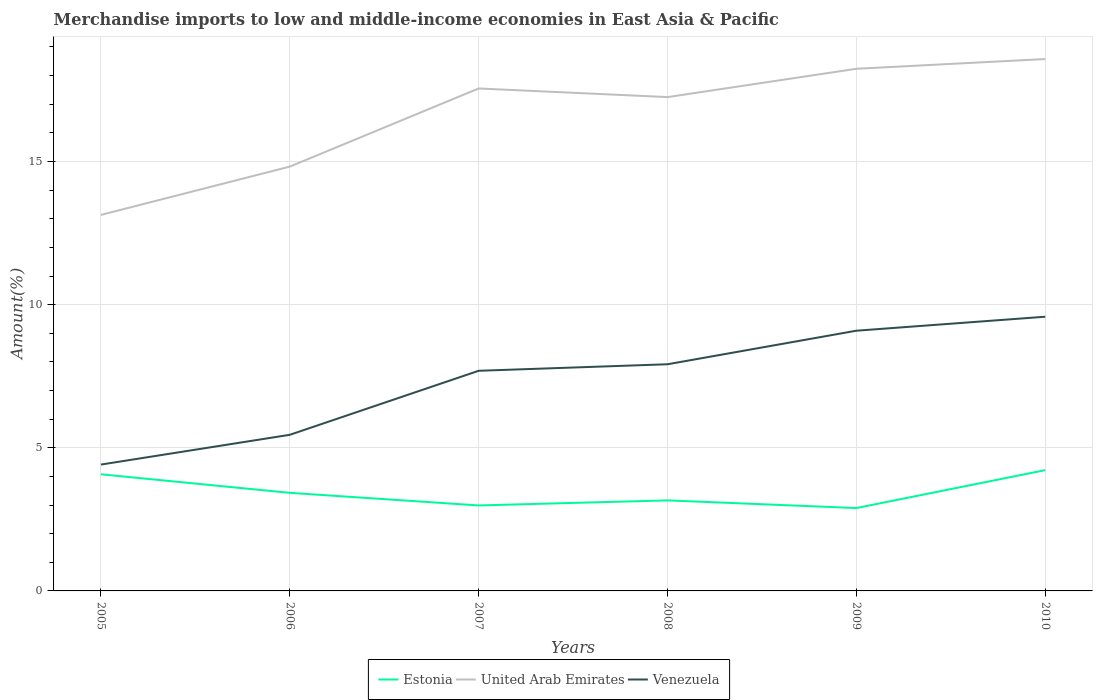How many different coloured lines are there?
Offer a very short reply. 3. Does the line corresponding to Venezuela intersect with the line corresponding to United Arab Emirates?
Offer a terse response. No. Across all years, what is the maximum percentage of amount earned from merchandise imports in Estonia?
Provide a succinct answer. 2.89. What is the total percentage of amount earned from merchandise imports in Estonia in the graph?
Provide a short and direct response. 0.53. What is the difference between the highest and the second highest percentage of amount earned from merchandise imports in United Arab Emirates?
Your answer should be compact. 5.44. What is the difference between the highest and the lowest percentage of amount earned from merchandise imports in Venezuela?
Offer a very short reply. 4. Is the percentage of amount earned from merchandise imports in Estonia strictly greater than the percentage of amount earned from merchandise imports in Venezuela over the years?
Your answer should be compact. Yes. How many lines are there?
Make the answer very short. 3. Does the graph contain any zero values?
Offer a very short reply. No. What is the title of the graph?
Your response must be concise. Merchandise imports to low and middle-income economies in East Asia & Pacific. Does "Cabo Verde" appear as one of the legend labels in the graph?
Ensure brevity in your answer.  No. What is the label or title of the X-axis?
Give a very brief answer. Years. What is the label or title of the Y-axis?
Provide a succinct answer. Amount(%). What is the Amount(%) in Estonia in 2005?
Your answer should be compact. 4.07. What is the Amount(%) in United Arab Emirates in 2005?
Offer a terse response. 13.13. What is the Amount(%) in Venezuela in 2005?
Your answer should be compact. 4.41. What is the Amount(%) in Estonia in 2006?
Give a very brief answer. 3.43. What is the Amount(%) of United Arab Emirates in 2006?
Your answer should be compact. 14.82. What is the Amount(%) of Venezuela in 2006?
Offer a very short reply. 5.45. What is the Amount(%) in Estonia in 2007?
Make the answer very short. 2.99. What is the Amount(%) in United Arab Emirates in 2007?
Offer a very short reply. 17.55. What is the Amount(%) in Venezuela in 2007?
Your response must be concise. 7.69. What is the Amount(%) of Estonia in 2008?
Your answer should be compact. 3.16. What is the Amount(%) of United Arab Emirates in 2008?
Your response must be concise. 17.25. What is the Amount(%) of Venezuela in 2008?
Your answer should be compact. 7.92. What is the Amount(%) of Estonia in 2009?
Keep it short and to the point. 2.89. What is the Amount(%) in United Arab Emirates in 2009?
Offer a terse response. 18.24. What is the Amount(%) in Venezuela in 2009?
Your answer should be very brief. 9.09. What is the Amount(%) in Estonia in 2010?
Provide a short and direct response. 4.22. What is the Amount(%) in United Arab Emirates in 2010?
Keep it short and to the point. 18.58. What is the Amount(%) of Venezuela in 2010?
Make the answer very short. 9.58. Across all years, what is the maximum Amount(%) in Estonia?
Give a very brief answer. 4.22. Across all years, what is the maximum Amount(%) in United Arab Emirates?
Your answer should be compact. 18.58. Across all years, what is the maximum Amount(%) in Venezuela?
Make the answer very short. 9.58. Across all years, what is the minimum Amount(%) of Estonia?
Make the answer very short. 2.89. Across all years, what is the minimum Amount(%) of United Arab Emirates?
Make the answer very short. 13.13. Across all years, what is the minimum Amount(%) of Venezuela?
Provide a short and direct response. 4.41. What is the total Amount(%) of Estonia in the graph?
Keep it short and to the point. 20.76. What is the total Amount(%) in United Arab Emirates in the graph?
Keep it short and to the point. 99.57. What is the total Amount(%) of Venezuela in the graph?
Give a very brief answer. 44.14. What is the difference between the Amount(%) of Estonia in 2005 and that in 2006?
Make the answer very short. 0.65. What is the difference between the Amount(%) in United Arab Emirates in 2005 and that in 2006?
Give a very brief answer. -1.69. What is the difference between the Amount(%) of Venezuela in 2005 and that in 2006?
Provide a short and direct response. -1.04. What is the difference between the Amount(%) in Estonia in 2005 and that in 2007?
Keep it short and to the point. 1.09. What is the difference between the Amount(%) in United Arab Emirates in 2005 and that in 2007?
Give a very brief answer. -4.42. What is the difference between the Amount(%) of Venezuela in 2005 and that in 2007?
Ensure brevity in your answer.  -3.28. What is the difference between the Amount(%) of Estonia in 2005 and that in 2008?
Your answer should be very brief. 0.91. What is the difference between the Amount(%) in United Arab Emirates in 2005 and that in 2008?
Give a very brief answer. -4.12. What is the difference between the Amount(%) in Venezuela in 2005 and that in 2008?
Your answer should be compact. -3.5. What is the difference between the Amount(%) of Estonia in 2005 and that in 2009?
Your answer should be very brief. 1.18. What is the difference between the Amount(%) of United Arab Emirates in 2005 and that in 2009?
Give a very brief answer. -5.1. What is the difference between the Amount(%) in Venezuela in 2005 and that in 2009?
Keep it short and to the point. -4.68. What is the difference between the Amount(%) of Estonia in 2005 and that in 2010?
Offer a very short reply. -0.15. What is the difference between the Amount(%) of United Arab Emirates in 2005 and that in 2010?
Ensure brevity in your answer.  -5.44. What is the difference between the Amount(%) of Venezuela in 2005 and that in 2010?
Keep it short and to the point. -5.16. What is the difference between the Amount(%) in Estonia in 2006 and that in 2007?
Your answer should be compact. 0.44. What is the difference between the Amount(%) of United Arab Emirates in 2006 and that in 2007?
Your response must be concise. -2.73. What is the difference between the Amount(%) in Venezuela in 2006 and that in 2007?
Your answer should be compact. -2.24. What is the difference between the Amount(%) in Estonia in 2006 and that in 2008?
Your answer should be very brief. 0.26. What is the difference between the Amount(%) of United Arab Emirates in 2006 and that in 2008?
Offer a very short reply. -2.43. What is the difference between the Amount(%) of Venezuela in 2006 and that in 2008?
Your answer should be compact. -2.46. What is the difference between the Amount(%) in Estonia in 2006 and that in 2009?
Your answer should be compact. 0.53. What is the difference between the Amount(%) in United Arab Emirates in 2006 and that in 2009?
Your answer should be very brief. -3.42. What is the difference between the Amount(%) of Venezuela in 2006 and that in 2009?
Your answer should be compact. -3.64. What is the difference between the Amount(%) of Estonia in 2006 and that in 2010?
Offer a terse response. -0.79. What is the difference between the Amount(%) in United Arab Emirates in 2006 and that in 2010?
Your response must be concise. -3.76. What is the difference between the Amount(%) of Venezuela in 2006 and that in 2010?
Provide a short and direct response. -4.12. What is the difference between the Amount(%) in Estonia in 2007 and that in 2008?
Your answer should be very brief. -0.18. What is the difference between the Amount(%) of United Arab Emirates in 2007 and that in 2008?
Offer a terse response. 0.3. What is the difference between the Amount(%) of Venezuela in 2007 and that in 2008?
Provide a short and direct response. -0.23. What is the difference between the Amount(%) of Estonia in 2007 and that in 2009?
Keep it short and to the point. 0.09. What is the difference between the Amount(%) of United Arab Emirates in 2007 and that in 2009?
Offer a very short reply. -0.69. What is the difference between the Amount(%) of Venezuela in 2007 and that in 2009?
Your answer should be compact. -1.4. What is the difference between the Amount(%) in Estonia in 2007 and that in 2010?
Offer a very short reply. -1.23. What is the difference between the Amount(%) in United Arab Emirates in 2007 and that in 2010?
Give a very brief answer. -1.03. What is the difference between the Amount(%) of Venezuela in 2007 and that in 2010?
Ensure brevity in your answer.  -1.89. What is the difference between the Amount(%) in Estonia in 2008 and that in 2009?
Provide a short and direct response. 0.27. What is the difference between the Amount(%) of United Arab Emirates in 2008 and that in 2009?
Your response must be concise. -0.99. What is the difference between the Amount(%) of Venezuela in 2008 and that in 2009?
Provide a short and direct response. -1.17. What is the difference between the Amount(%) in Estonia in 2008 and that in 2010?
Offer a terse response. -1.06. What is the difference between the Amount(%) of United Arab Emirates in 2008 and that in 2010?
Your answer should be compact. -1.33. What is the difference between the Amount(%) of Venezuela in 2008 and that in 2010?
Provide a short and direct response. -1.66. What is the difference between the Amount(%) of Estonia in 2009 and that in 2010?
Offer a terse response. -1.33. What is the difference between the Amount(%) of United Arab Emirates in 2009 and that in 2010?
Provide a succinct answer. -0.34. What is the difference between the Amount(%) in Venezuela in 2009 and that in 2010?
Ensure brevity in your answer.  -0.49. What is the difference between the Amount(%) in Estonia in 2005 and the Amount(%) in United Arab Emirates in 2006?
Give a very brief answer. -10.75. What is the difference between the Amount(%) in Estonia in 2005 and the Amount(%) in Venezuela in 2006?
Offer a terse response. -1.38. What is the difference between the Amount(%) of United Arab Emirates in 2005 and the Amount(%) of Venezuela in 2006?
Keep it short and to the point. 7.68. What is the difference between the Amount(%) in Estonia in 2005 and the Amount(%) in United Arab Emirates in 2007?
Offer a terse response. -13.48. What is the difference between the Amount(%) in Estonia in 2005 and the Amount(%) in Venezuela in 2007?
Make the answer very short. -3.62. What is the difference between the Amount(%) in United Arab Emirates in 2005 and the Amount(%) in Venezuela in 2007?
Your response must be concise. 5.45. What is the difference between the Amount(%) of Estonia in 2005 and the Amount(%) of United Arab Emirates in 2008?
Ensure brevity in your answer.  -13.18. What is the difference between the Amount(%) in Estonia in 2005 and the Amount(%) in Venezuela in 2008?
Your response must be concise. -3.84. What is the difference between the Amount(%) in United Arab Emirates in 2005 and the Amount(%) in Venezuela in 2008?
Your response must be concise. 5.22. What is the difference between the Amount(%) in Estonia in 2005 and the Amount(%) in United Arab Emirates in 2009?
Ensure brevity in your answer.  -14.16. What is the difference between the Amount(%) in Estonia in 2005 and the Amount(%) in Venezuela in 2009?
Your response must be concise. -5.02. What is the difference between the Amount(%) of United Arab Emirates in 2005 and the Amount(%) of Venezuela in 2009?
Your response must be concise. 4.04. What is the difference between the Amount(%) in Estonia in 2005 and the Amount(%) in United Arab Emirates in 2010?
Make the answer very short. -14.5. What is the difference between the Amount(%) in Estonia in 2005 and the Amount(%) in Venezuela in 2010?
Make the answer very short. -5.5. What is the difference between the Amount(%) of United Arab Emirates in 2005 and the Amount(%) of Venezuela in 2010?
Give a very brief answer. 3.56. What is the difference between the Amount(%) in Estonia in 2006 and the Amount(%) in United Arab Emirates in 2007?
Your answer should be very brief. -14.12. What is the difference between the Amount(%) of Estonia in 2006 and the Amount(%) of Venezuela in 2007?
Your response must be concise. -4.26. What is the difference between the Amount(%) of United Arab Emirates in 2006 and the Amount(%) of Venezuela in 2007?
Your answer should be very brief. 7.13. What is the difference between the Amount(%) of Estonia in 2006 and the Amount(%) of United Arab Emirates in 2008?
Your answer should be compact. -13.82. What is the difference between the Amount(%) of Estonia in 2006 and the Amount(%) of Venezuela in 2008?
Your response must be concise. -4.49. What is the difference between the Amount(%) of United Arab Emirates in 2006 and the Amount(%) of Venezuela in 2008?
Make the answer very short. 6.9. What is the difference between the Amount(%) in Estonia in 2006 and the Amount(%) in United Arab Emirates in 2009?
Make the answer very short. -14.81. What is the difference between the Amount(%) in Estonia in 2006 and the Amount(%) in Venezuela in 2009?
Offer a terse response. -5.66. What is the difference between the Amount(%) in United Arab Emirates in 2006 and the Amount(%) in Venezuela in 2009?
Give a very brief answer. 5.73. What is the difference between the Amount(%) of Estonia in 2006 and the Amount(%) of United Arab Emirates in 2010?
Make the answer very short. -15.15. What is the difference between the Amount(%) in Estonia in 2006 and the Amount(%) in Venezuela in 2010?
Make the answer very short. -6.15. What is the difference between the Amount(%) of United Arab Emirates in 2006 and the Amount(%) of Venezuela in 2010?
Provide a short and direct response. 5.24. What is the difference between the Amount(%) in Estonia in 2007 and the Amount(%) in United Arab Emirates in 2008?
Ensure brevity in your answer.  -14.26. What is the difference between the Amount(%) of Estonia in 2007 and the Amount(%) of Venezuela in 2008?
Offer a very short reply. -4.93. What is the difference between the Amount(%) of United Arab Emirates in 2007 and the Amount(%) of Venezuela in 2008?
Offer a very short reply. 9.63. What is the difference between the Amount(%) of Estonia in 2007 and the Amount(%) of United Arab Emirates in 2009?
Ensure brevity in your answer.  -15.25. What is the difference between the Amount(%) of Estonia in 2007 and the Amount(%) of Venezuela in 2009?
Give a very brief answer. -6.1. What is the difference between the Amount(%) in United Arab Emirates in 2007 and the Amount(%) in Venezuela in 2009?
Your answer should be compact. 8.46. What is the difference between the Amount(%) of Estonia in 2007 and the Amount(%) of United Arab Emirates in 2010?
Keep it short and to the point. -15.59. What is the difference between the Amount(%) of Estonia in 2007 and the Amount(%) of Venezuela in 2010?
Ensure brevity in your answer.  -6.59. What is the difference between the Amount(%) in United Arab Emirates in 2007 and the Amount(%) in Venezuela in 2010?
Ensure brevity in your answer.  7.97. What is the difference between the Amount(%) of Estonia in 2008 and the Amount(%) of United Arab Emirates in 2009?
Provide a short and direct response. -15.08. What is the difference between the Amount(%) of Estonia in 2008 and the Amount(%) of Venezuela in 2009?
Make the answer very short. -5.93. What is the difference between the Amount(%) of United Arab Emirates in 2008 and the Amount(%) of Venezuela in 2009?
Ensure brevity in your answer.  8.16. What is the difference between the Amount(%) of Estonia in 2008 and the Amount(%) of United Arab Emirates in 2010?
Make the answer very short. -15.42. What is the difference between the Amount(%) in Estonia in 2008 and the Amount(%) in Venezuela in 2010?
Offer a very short reply. -6.42. What is the difference between the Amount(%) of United Arab Emirates in 2008 and the Amount(%) of Venezuela in 2010?
Provide a short and direct response. 7.67. What is the difference between the Amount(%) in Estonia in 2009 and the Amount(%) in United Arab Emirates in 2010?
Your answer should be compact. -15.68. What is the difference between the Amount(%) in Estonia in 2009 and the Amount(%) in Venezuela in 2010?
Provide a succinct answer. -6.68. What is the difference between the Amount(%) of United Arab Emirates in 2009 and the Amount(%) of Venezuela in 2010?
Give a very brief answer. 8.66. What is the average Amount(%) in Estonia per year?
Give a very brief answer. 3.46. What is the average Amount(%) in United Arab Emirates per year?
Provide a short and direct response. 16.6. What is the average Amount(%) in Venezuela per year?
Offer a very short reply. 7.36. In the year 2005, what is the difference between the Amount(%) of Estonia and Amount(%) of United Arab Emirates?
Provide a succinct answer. -9.06. In the year 2005, what is the difference between the Amount(%) of Estonia and Amount(%) of Venezuela?
Give a very brief answer. -0.34. In the year 2005, what is the difference between the Amount(%) of United Arab Emirates and Amount(%) of Venezuela?
Provide a succinct answer. 8.72. In the year 2006, what is the difference between the Amount(%) of Estonia and Amount(%) of United Arab Emirates?
Offer a terse response. -11.39. In the year 2006, what is the difference between the Amount(%) in Estonia and Amount(%) in Venezuela?
Your answer should be very brief. -2.03. In the year 2006, what is the difference between the Amount(%) in United Arab Emirates and Amount(%) in Venezuela?
Offer a terse response. 9.37. In the year 2007, what is the difference between the Amount(%) of Estonia and Amount(%) of United Arab Emirates?
Provide a short and direct response. -14.56. In the year 2007, what is the difference between the Amount(%) in Estonia and Amount(%) in Venezuela?
Give a very brief answer. -4.7. In the year 2007, what is the difference between the Amount(%) of United Arab Emirates and Amount(%) of Venezuela?
Keep it short and to the point. 9.86. In the year 2008, what is the difference between the Amount(%) of Estonia and Amount(%) of United Arab Emirates?
Provide a succinct answer. -14.09. In the year 2008, what is the difference between the Amount(%) of Estonia and Amount(%) of Venezuela?
Give a very brief answer. -4.76. In the year 2008, what is the difference between the Amount(%) in United Arab Emirates and Amount(%) in Venezuela?
Your response must be concise. 9.33. In the year 2009, what is the difference between the Amount(%) in Estonia and Amount(%) in United Arab Emirates?
Ensure brevity in your answer.  -15.34. In the year 2009, what is the difference between the Amount(%) in Estonia and Amount(%) in Venezuela?
Your answer should be compact. -6.19. In the year 2009, what is the difference between the Amount(%) of United Arab Emirates and Amount(%) of Venezuela?
Provide a succinct answer. 9.15. In the year 2010, what is the difference between the Amount(%) of Estonia and Amount(%) of United Arab Emirates?
Your answer should be very brief. -14.36. In the year 2010, what is the difference between the Amount(%) of Estonia and Amount(%) of Venezuela?
Make the answer very short. -5.36. In the year 2010, what is the difference between the Amount(%) of United Arab Emirates and Amount(%) of Venezuela?
Ensure brevity in your answer.  9. What is the ratio of the Amount(%) in Estonia in 2005 to that in 2006?
Give a very brief answer. 1.19. What is the ratio of the Amount(%) of United Arab Emirates in 2005 to that in 2006?
Your answer should be compact. 0.89. What is the ratio of the Amount(%) in Venezuela in 2005 to that in 2006?
Make the answer very short. 0.81. What is the ratio of the Amount(%) in Estonia in 2005 to that in 2007?
Your response must be concise. 1.36. What is the ratio of the Amount(%) of United Arab Emirates in 2005 to that in 2007?
Offer a very short reply. 0.75. What is the ratio of the Amount(%) in Venezuela in 2005 to that in 2007?
Provide a succinct answer. 0.57. What is the ratio of the Amount(%) in Estonia in 2005 to that in 2008?
Provide a short and direct response. 1.29. What is the ratio of the Amount(%) in United Arab Emirates in 2005 to that in 2008?
Make the answer very short. 0.76. What is the ratio of the Amount(%) in Venezuela in 2005 to that in 2008?
Offer a terse response. 0.56. What is the ratio of the Amount(%) of Estonia in 2005 to that in 2009?
Keep it short and to the point. 1.41. What is the ratio of the Amount(%) of United Arab Emirates in 2005 to that in 2009?
Your response must be concise. 0.72. What is the ratio of the Amount(%) in Venezuela in 2005 to that in 2009?
Make the answer very short. 0.49. What is the ratio of the Amount(%) in Estonia in 2005 to that in 2010?
Offer a very short reply. 0.97. What is the ratio of the Amount(%) in United Arab Emirates in 2005 to that in 2010?
Provide a short and direct response. 0.71. What is the ratio of the Amount(%) in Venezuela in 2005 to that in 2010?
Your answer should be very brief. 0.46. What is the ratio of the Amount(%) of Estonia in 2006 to that in 2007?
Provide a short and direct response. 1.15. What is the ratio of the Amount(%) in United Arab Emirates in 2006 to that in 2007?
Your response must be concise. 0.84. What is the ratio of the Amount(%) in Venezuela in 2006 to that in 2007?
Your answer should be very brief. 0.71. What is the ratio of the Amount(%) of Estonia in 2006 to that in 2008?
Offer a very short reply. 1.08. What is the ratio of the Amount(%) in United Arab Emirates in 2006 to that in 2008?
Offer a very short reply. 0.86. What is the ratio of the Amount(%) of Venezuela in 2006 to that in 2008?
Make the answer very short. 0.69. What is the ratio of the Amount(%) of Estonia in 2006 to that in 2009?
Ensure brevity in your answer.  1.18. What is the ratio of the Amount(%) in United Arab Emirates in 2006 to that in 2009?
Your response must be concise. 0.81. What is the ratio of the Amount(%) of Venezuela in 2006 to that in 2009?
Offer a terse response. 0.6. What is the ratio of the Amount(%) in Estonia in 2006 to that in 2010?
Your answer should be compact. 0.81. What is the ratio of the Amount(%) of United Arab Emirates in 2006 to that in 2010?
Your answer should be very brief. 0.8. What is the ratio of the Amount(%) of Venezuela in 2006 to that in 2010?
Offer a terse response. 0.57. What is the ratio of the Amount(%) in Estonia in 2007 to that in 2008?
Make the answer very short. 0.94. What is the ratio of the Amount(%) in United Arab Emirates in 2007 to that in 2008?
Make the answer very short. 1.02. What is the ratio of the Amount(%) in Venezuela in 2007 to that in 2008?
Provide a succinct answer. 0.97. What is the ratio of the Amount(%) of Estonia in 2007 to that in 2009?
Your answer should be compact. 1.03. What is the ratio of the Amount(%) of United Arab Emirates in 2007 to that in 2009?
Your response must be concise. 0.96. What is the ratio of the Amount(%) in Venezuela in 2007 to that in 2009?
Your answer should be very brief. 0.85. What is the ratio of the Amount(%) of Estonia in 2007 to that in 2010?
Ensure brevity in your answer.  0.71. What is the ratio of the Amount(%) in United Arab Emirates in 2007 to that in 2010?
Your answer should be compact. 0.94. What is the ratio of the Amount(%) of Venezuela in 2007 to that in 2010?
Your response must be concise. 0.8. What is the ratio of the Amount(%) of Estonia in 2008 to that in 2009?
Provide a short and direct response. 1.09. What is the ratio of the Amount(%) in United Arab Emirates in 2008 to that in 2009?
Your answer should be compact. 0.95. What is the ratio of the Amount(%) of Venezuela in 2008 to that in 2009?
Offer a terse response. 0.87. What is the ratio of the Amount(%) in Estonia in 2008 to that in 2010?
Keep it short and to the point. 0.75. What is the ratio of the Amount(%) of United Arab Emirates in 2008 to that in 2010?
Provide a succinct answer. 0.93. What is the ratio of the Amount(%) in Venezuela in 2008 to that in 2010?
Give a very brief answer. 0.83. What is the ratio of the Amount(%) in Estonia in 2009 to that in 2010?
Your answer should be compact. 0.69. What is the ratio of the Amount(%) of United Arab Emirates in 2009 to that in 2010?
Give a very brief answer. 0.98. What is the ratio of the Amount(%) of Venezuela in 2009 to that in 2010?
Your response must be concise. 0.95. What is the difference between the highest and the second highest Amount(%) of Estonia?
Your answer should be compact. 0.15. What is the difference between the highest and the second highest Amount(%) in United Arab Emirates?
Your answer should be very brief. 0.34. What is the difference between the highest and the second highest Amount(%) of Venezuela?
Provide a succinct answer. 0.49. What is the difference between the highest and the lowest Amount(%) of Estonia?
Offer a very short reply. 1.33. What is the difference between the highest and the lowest Amount(%) in United Arab Emirates?
Your answer should be very brief. 5.44. What is the difference between the highest and the lowest Amount(%) in Venezuela?
Ensure brevity in your answer.  5.16. 